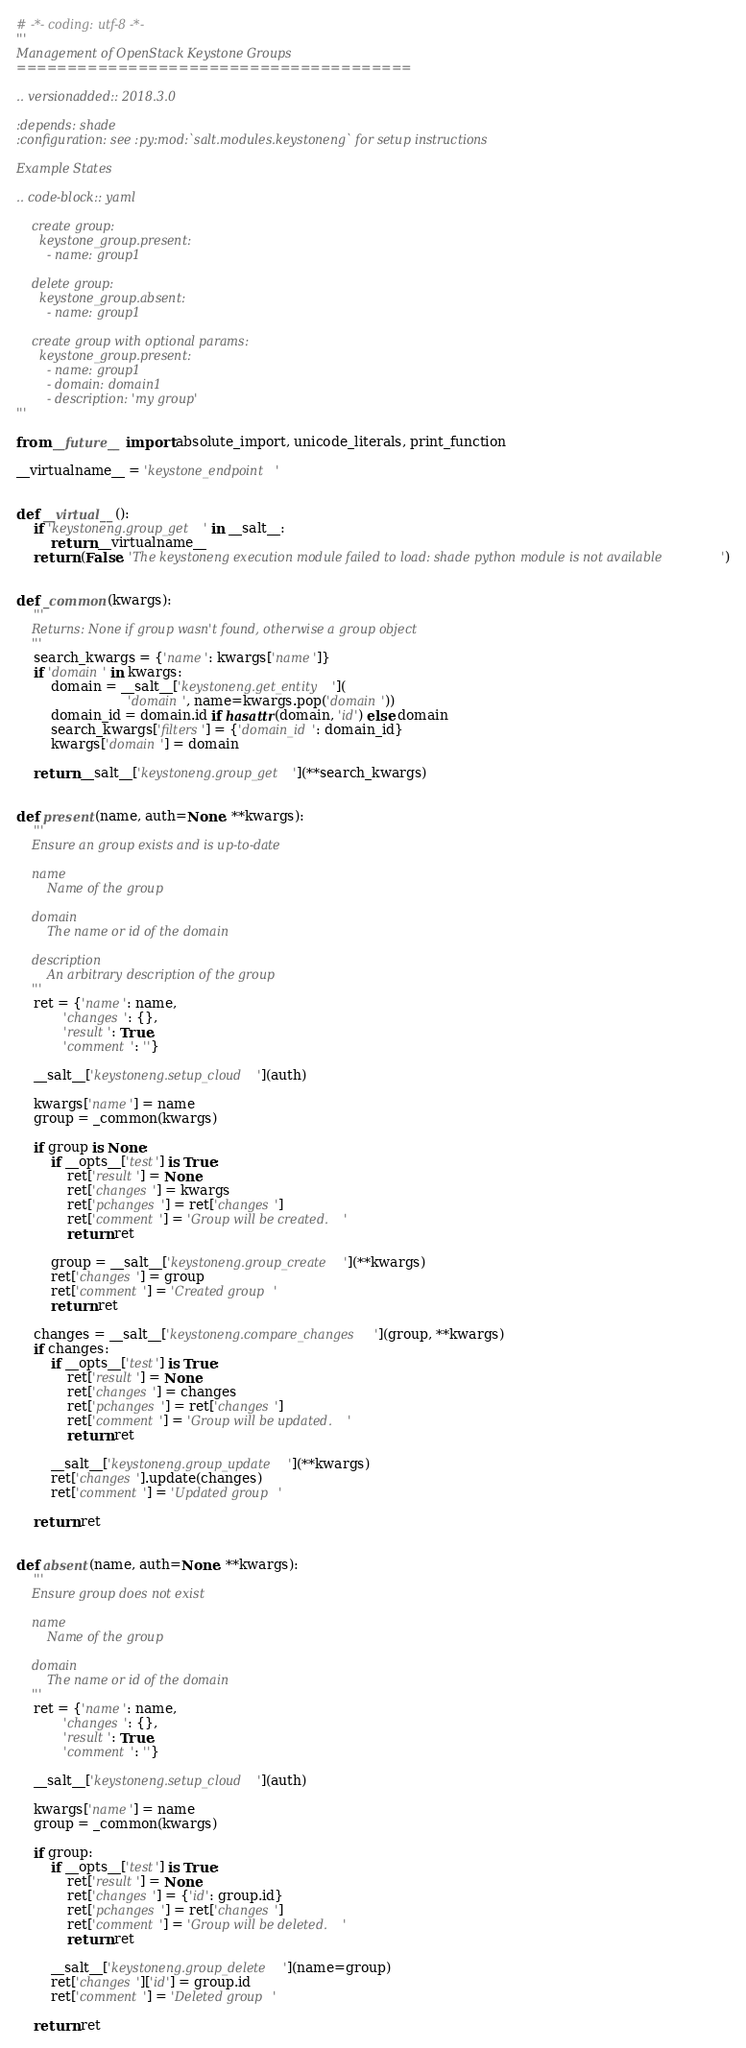<code> <loc_0><loc_0><loc_500><loc_500><_Python_># -*- coding: utf-8 -*-
'''
Management of OpenStack Keystone Groups
=======================================

.. versionadded:: 2018.3.0

:depends: shade
:configuration: see :py:mod:`salt.modules.keystoneng` for setup instructions

Example States

.. code-block:: yaml

    create group:
      keystone_group.present:
        - name: group1

    delete group:
      keystone_group.absent:
        - name: group1

    create group with optional params:
      keystone_group.present:
        - name: group1
        - domain: domain1
        - description: 'my group'
'''

from __future__ import absolute_import, unicode_literals, print_function

__virtualname__ = 'keystone_endpoint'


def __virtual__():
    if 'keystoneng.group_get' in __salt__:
        return __virtualname__
    return (False, 'The keystoneng execution module failed to load: shade python module is not available')


def _common(kwargs):
    '''
    Returns: None if group wasn't found, otherwise a group object
    '''
    search_kwargs = {'name': kwargs['name']}
    if 'domain' in kwargs:
        domain = __salt__['keystoneng.get_entity'](
                          'domain', name=kwargs.pop('domain'))
        domain_id = domain.id if hasattr(domain, 'id') else domain
        search_kwargs['filters'] = {'domain_id': domain_id}
        kwargs['domain'] = domain

    return __salt__['keystoneng.group_get'](**search_kwargs)


def present(name, auth=None, **kwargs):
    '''
    Ensure an group exists and is up-to-date

    name
        Name of the group

    domain
        The name or id of the domain

    description
        An arbitrary description of the group
    '''
    ret = {'name': name,
           'changes': {},
           'result': True,
           'comment': ''}

    __salt__['keystoneng.setup_cloud'](auth)

    kwargs['name'] = name
    group = _common(kwargs)

    if group is None:
        if __opts__['test'] is True:
            ret['result'] = None
            ret['changes'] = kwargs
            ret['pchanges'] = ret['changes']
            ret['comment'] = 'Group will be created.'
            return ret

        group = __salt__['keystoneng.group_create'](**kwargs)
        ret['changes'] = group
        ret['comment'] = 'Created group'
        return ret

    changes = __salt__['keystoneng.compare_changes'](group, **kwargs)
    if changes:
        if __opts__['test'] is True:
            ret['result'] = None
            ret['changes'] = changes
            ret['pchanges'] = ret['changes']
            ret['comment'] = 'Group will be updated.'
            return ret

        __salt__['keystoneng.group_update'](**kwargs)
        ret['changes'].update(changes)
        ret['comment'] = 'Updated group'

    return ret


def absent(name, auth=None, **kwargs):
    '''
    Ensure group does not exist

    name
        Name of the group

    domain
        The name or id of the domain
    '''
    ret = {'name': name,
           'changes': {},
           'result': True,
           'comment': ''}

    __salt__['keystoneng.setup_cloud'](auth)

    kwargs['name'] = name
    group = _common(kwargs)

    if group:
        if __opts__['test'] is True:
            ret['result'] = None
            ret['changes'] = {'id': group.id}
            ret['pchanges'] = ret['changes']
            ret['comment'] = 'Group will be deleted.'
            return ret

        __salt__['keystoneng.group_delete'](name=group)
        ret['changes']['id'] = group.id
        ret['comment'] = 'Deleted group'

    return ret
</code> 